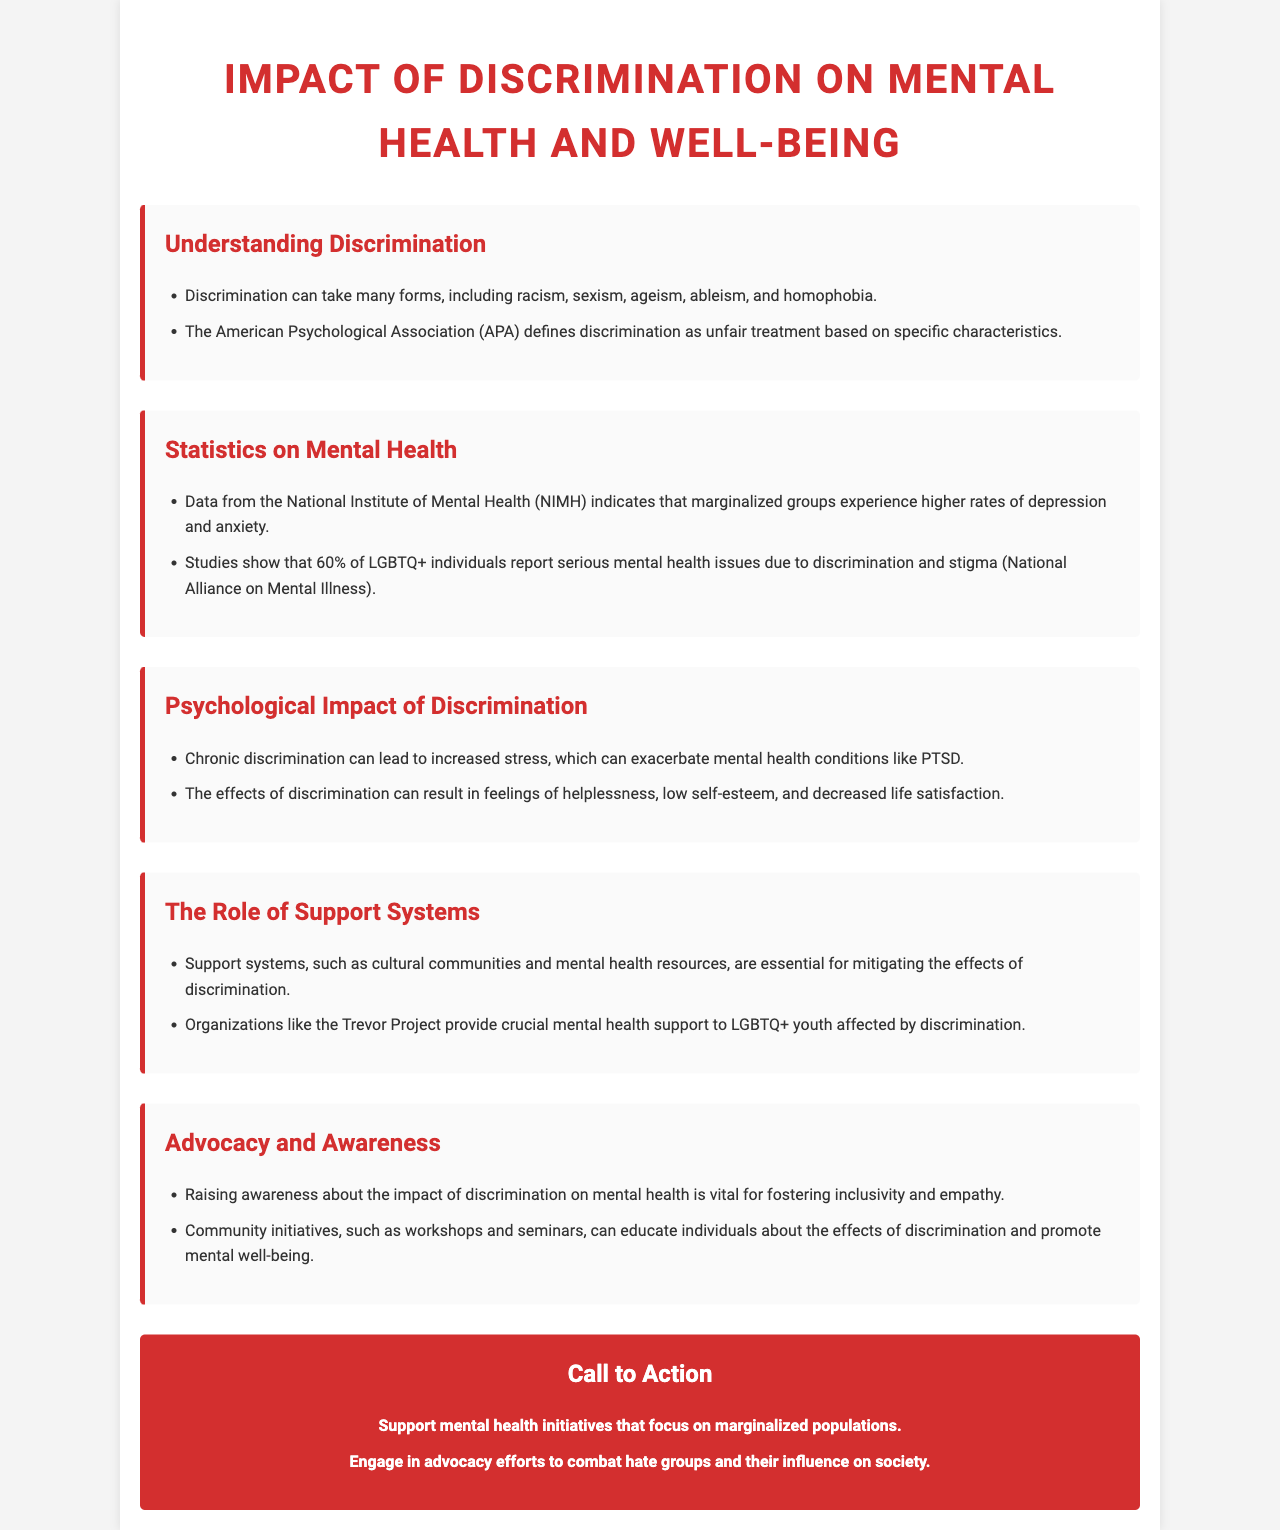What forms can discrimination take? The document lists various forms of discrimination including racism, sexism, ageism, ableism, and homophobia.
Answer: Racism, sexism, ageism, ableism, homophobia What percentage of LGBTQ+ individuals report serious mental health issues due to discrimination? According to the National Alliance on Mental Illness, 60% of LGBTQ+ individuals report serious mental health issues due to discrimination and stigma.
Answer: 60% What can chronic discrimination lead to? The document states that chronic discrimination can lead to increased stress and exacerbate mental health conditions like PTSD.
Answer: Increased stress What kind of support do organizations like the Trevor Project provide? The Trevor Project is mentioned as providing crucial mental health support to LGBTQ+ youth affected by discrimination.
Answer: Mental health support What is a vital action for fostering inclusivity according to the document? Raising awareness about the impact of discrimination on mental health is viewed as vital for fostering inclusivity and empathy.
Answer: Raising awareness What does the call to action encourage? The call to action includes encouraging support for mental health initiatives that focus on marginalized populations.
Answer: Support mental health initiatives How does chronic discrimination affect feelings? It can result in feelings of helplessness, low self-esteem, and decreased life satisfaction.
Answer: Helplessness, low self-esteem, decreased life satisfaction What role do support systems play in the effects of discrimination? Support systems are described as essential for mitigating the effects of discrimination.
Answer: Mitigating the effects of discrimination 